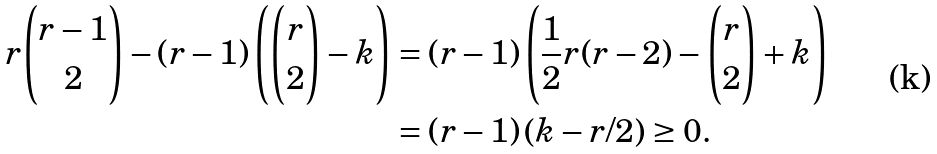Convert formula to latex. <formula><loc_0><loc_0><loc_500><loc_500>r \binom { r - 1 } { 2 } - ( r - 1 ) \left ( \binom { r } { 2 } - k \right ) & = ( r - 1 ) \left ( \frac { 1 } { 2 } r ( r - 2 ) - \binom { r } { 2 } + k \right ) \\ & = ( r - 1 ) \left ( k - r / 2 \right ) \geq 0 .</formula> 